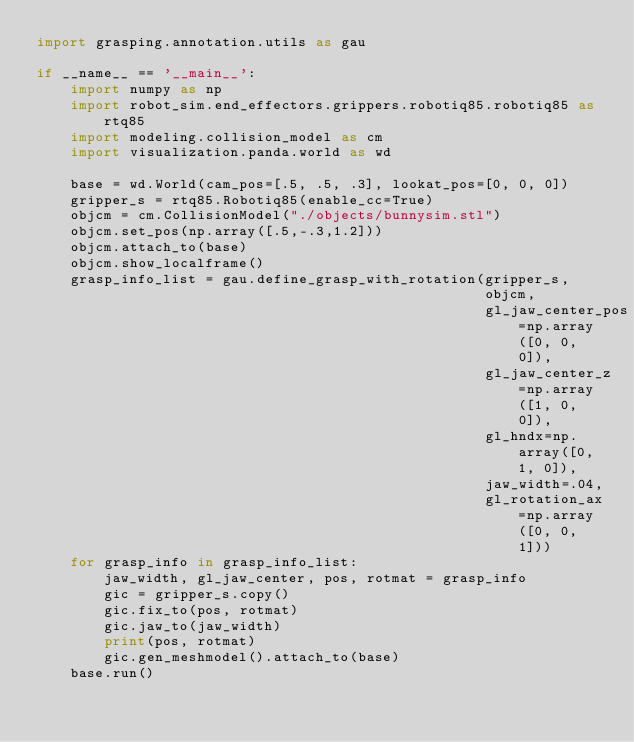Convert code to text. <code><loc_0><loc_0><loc_500><loc_500><_Python_>import grasping.annotation.utils as gau

if __name__ == '__main__':
    import numpy as np
    import robot_sim.end_effectors.grippers.robotiq85.robotiq85 as rtq85
    import modeling.collision_model as cm
    import visualization.panda.world as wd

    base = wd.World(cam_pos=[.5, .5, .3], lookat_pos=[0, 0, 0])
    gripper_s = rtq85.Robotiq85(enable_cc=True)
    objcm = cm.CollisionModel("./objects/bunnysim.stl")
    objcm.set_pos(np.array([.5,-.3,1.2]))
    objcm.attach_to(base)
    objcm.show_localframe()
    grasp_info_list = gau.define_grasp_with_rotation(gripper_s,
                                                     objcm,
                                                     gl_jaw_center_pos=np.array([0, 0, 0]),
                                                     gl_jaw_center_z=np.array([1, 0, 0]),
                                                     gl_hndx=np.array([0, 1, 0]),
                                                     jaw_width=.04,
                                                     gl_rotation_ax=np.array([0, 0, 1]))
    for grasp_info in grasp_info_list:
        jaw_width, gl_jaw_center, pos, rotmat = grasp_info
        gic = gripper_s.copy()
        gic.fix_to(pos, rotmat)
        gic.jaw_to(jaw_width)
        print(pos, rotmat)
        gic.gen_meshmodel().attach_to(base)
    base.run()
</code> 